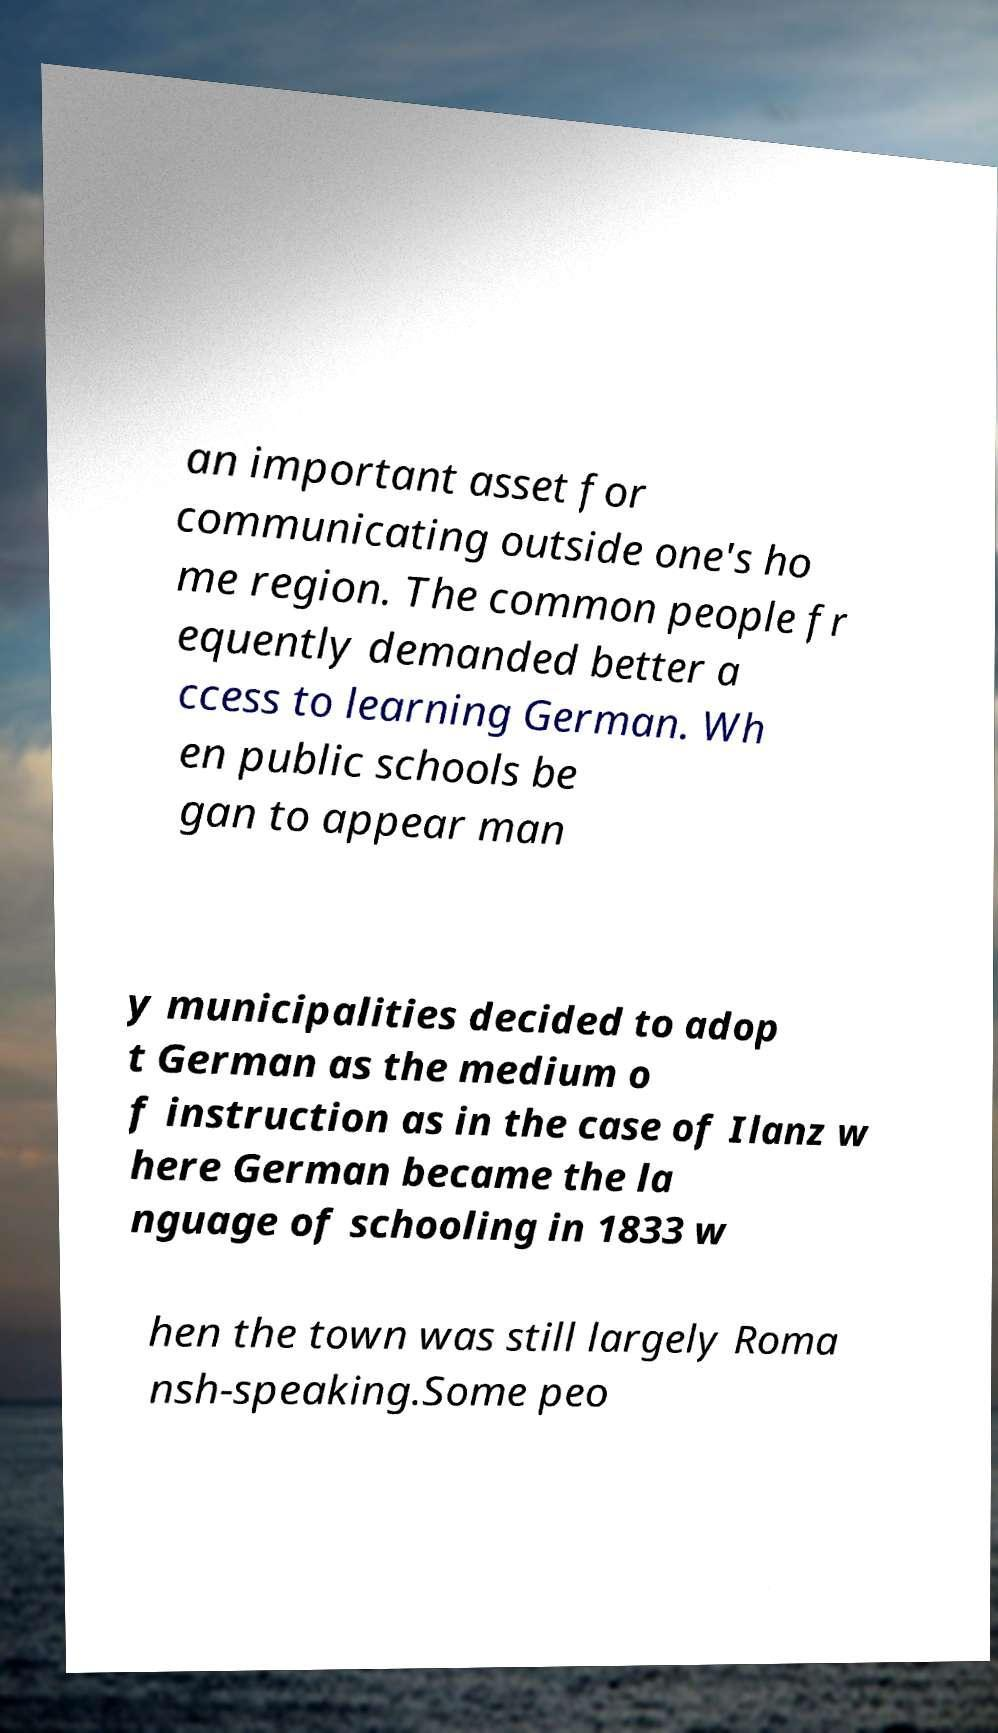Could you extract and type out the text from this image? an important asset for communicating outside one's ho me region. The common people fr equently demanded better a ccess to learning German. Wh en public schools be gan to appear man y municipalities decided to adop t German as the medium o f instruction as in the case of Ilanz w here German became the la nguage of schooling in 1833 w hen the town was still largely Roma nsh-speaking.Some peo 